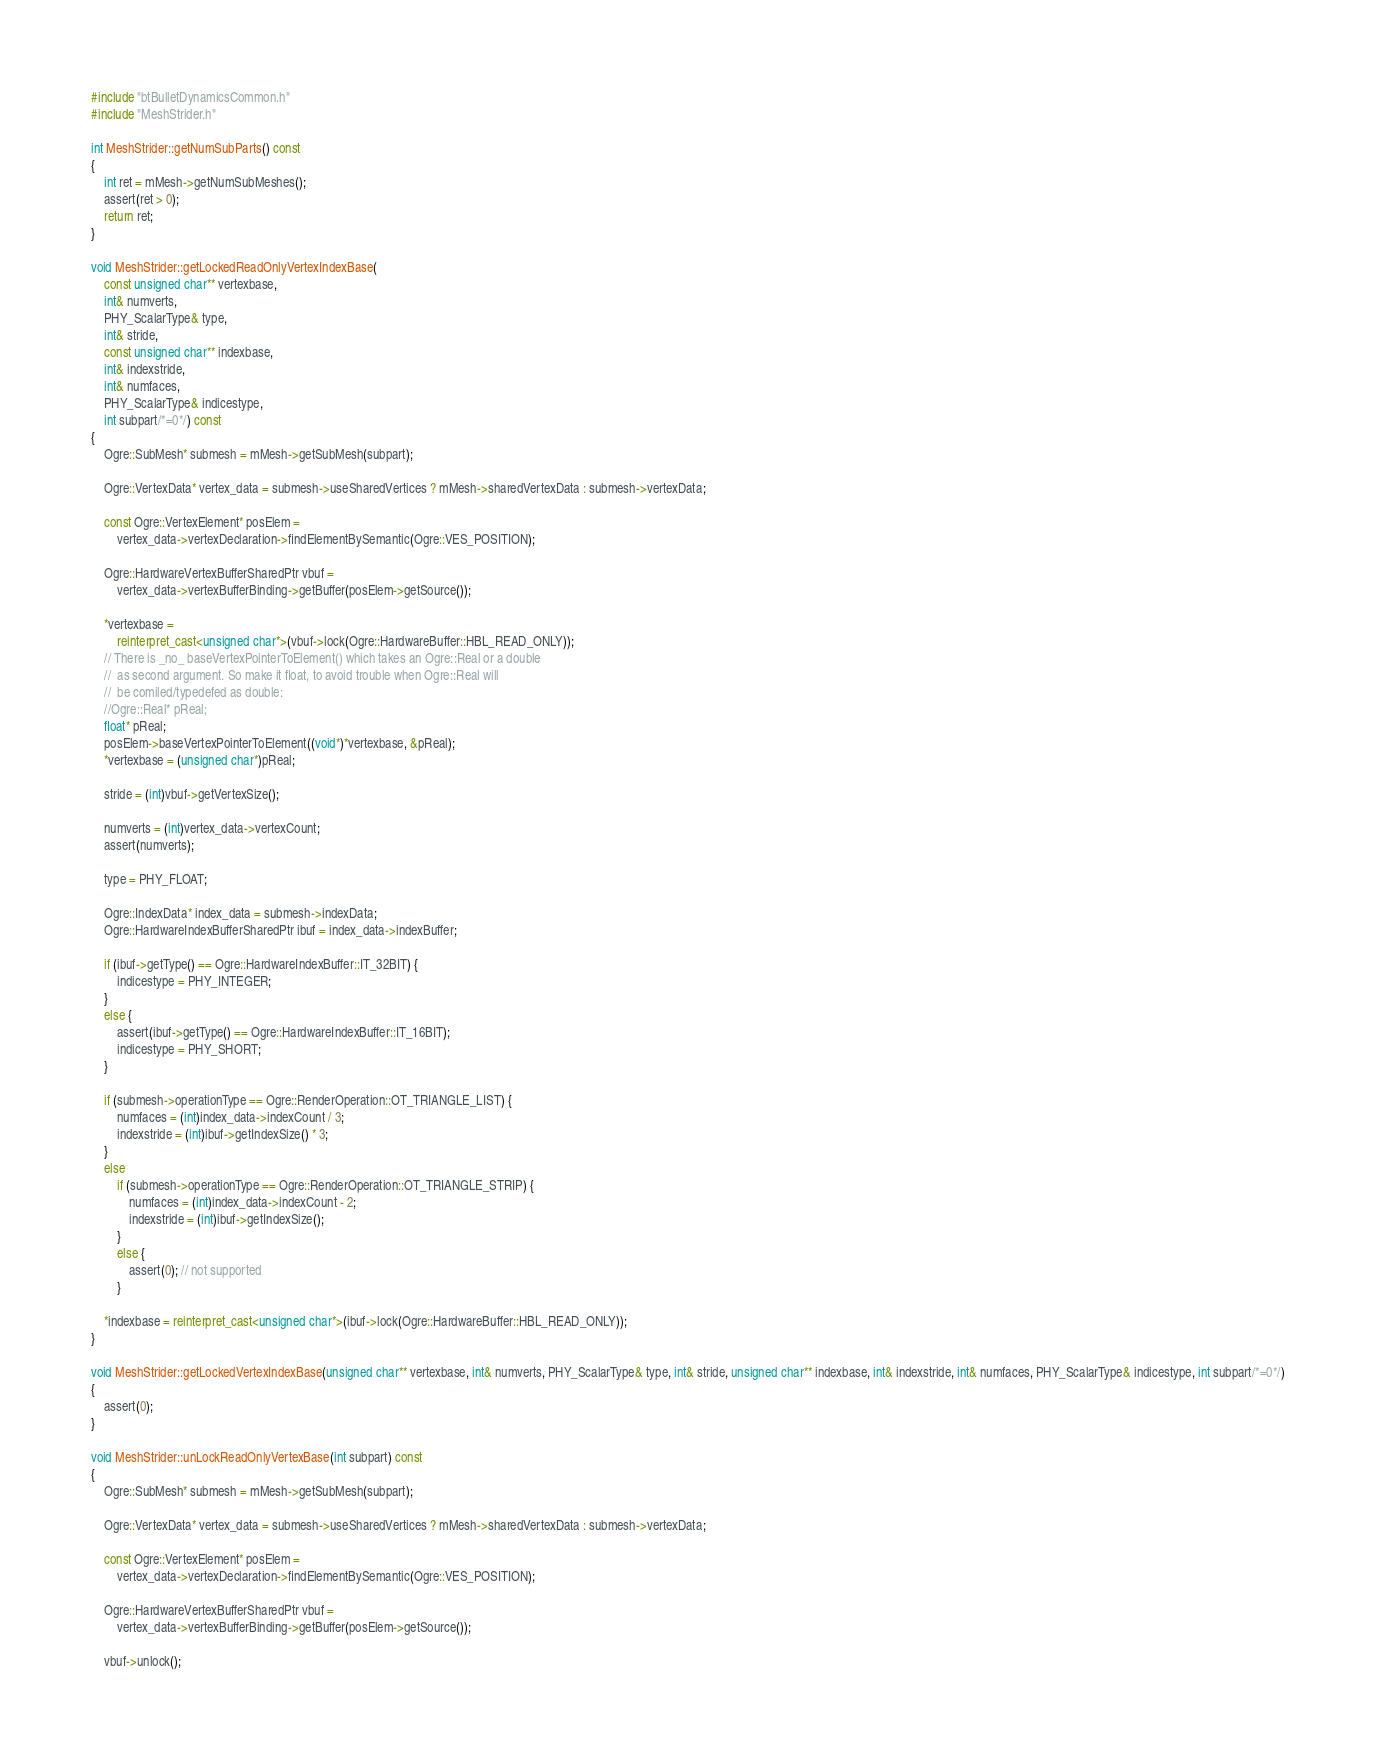<code> <loc_0><loc_0><loc_500><loc_500><_C++_>#include "btBulletDynamicsCommon.h"
#include "MeshStrider.h"

int MeshStrider::getNumSubParts() const
{
    int ret = mMesh->getNumSubMeshes();
    assert(ret > 0);
    return ret;
}

void MeshStrider::getLockedReadOnlyVertexIndexBase(
    const unsigned char** vertexbase,
    int& numverts,
    PHY_ScalarType& type,
    int& stride,
    const unsigned char** indexbase,
    int& indexstride,
    int& numfaces,
    PHY_ScalarType& indicestype,
    int subpart/*=0*/) const
{
    Ogre::SubMesh* submesh = mMesh->getSubMesh(subpart);

    Ogre::VertexData* vertex_data = submesh->useSharedVertices ? mMesh->sharedVertexData : submesh->vertexData;

    const Ogre::VertexElement* posElem =
        vertex_data->vertexDeclaration->findElementBySemantic(Ogre::VES_POSITION);

    Ogre::HardwareVertexBufferSharedPtr vbuf =
        vertex_data->vertexBufferBinding->getBuffer(posElem->getSource());

    *vertexbase =
        reinterpret_cast<unsigned char*>(vbuf->lock(Ogre::HardwareBuffer::HBL_READ_ONLY));
    // There is _no_ baseVertexPointerToElement() which takes an Ogre::Real or a double
    //  as second argument. So make it float, to avoid trouble when Ogre::Real will
    //  be comiled/typedefed as double:
    //Ogre::Real* pReal;
    float* pReal;
    posElem->baseVertexPointerToElement((void*)*vertexbase, &pReal);
    *vertexbase = (unsigned char*)pReal;

    stride = (int)vbuf->getVertexSize();

    numverts = (int)vertex_data->vertexCount;
    assert(numverts);

    type = PHY_FLOAT;

    Ogre::IndexData* index_data = submesh->indexData;
    Ogre::HardwareIndexBufferSharedPtr ibuf = index_data->indexBuffer;

    if (ibuf->getType() == Ogre::HardwareIndexBuffer::IT_32BIT) {
        indicestype = PHY_INTEGER;
    }
    else {
        assert(ibuf->getType() == Ogre::HardwareIndexBuffer::IT_16BIT);
        indicestype = PHY_SHORT;
    }

    if (submesh->operationType == Ogre::RenderOperation::OT_TRIANGLE_LIST) {
        numfaces = (int)index_data->indexCount / 3;
        indexstride = (int)ibuf->getIndexSize() * 3;
    }
    else
        if (submesh->operationType == Ogre::RenderOperation::OT_TRIANGLE_STRIP) {
            numfaces = (int)index_data->indexCount - 2;
            indexstride = (int)ibuf->getIndexSize();
        }
        else {
            assert(0); // not supported
        }

    *indexbase = reinterpret_cast<unsigned char*>(ibuf->lock(Ogre::HardwareBuffer::HBL_READ_ONLY));
}

void MeshStrider::getLockedVertexIndexBase(unsigned char** vertexbase, int& numverts, PHY_ScalarType& type, int& stride, unsigned char** indexbase, int& indexstride, int& numfaces, PHY_ScalarType& indicestype, int subpart/*=0*/)
{
    assert(0);
}

void MeshStrider::unLockReadOnlyVertexBase(int subpart) const
{
    Ogre::SubMesh* submesh = mMesh->getSubMesh(subpart);

    Ogre::VertexData* vertex_data = submesh->useSharedVertices ? mMesh->sharedVertexData : submesh->vertexData;

    const Ogre::VertexElement* posElem =
        vertex_data->vertexDeclaration->findElementBySemantic(Ogre::VES_POSITION);

    Ogre::HardwareVertexBufferSharedPtr vbuf =
        vertex_data->vertexBufferBinding->getBuffer(posElem->getSource());

    vbuf->unlock();
</code> 